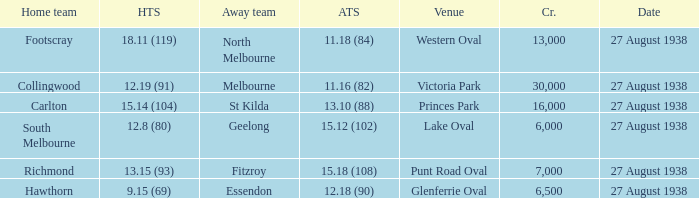How many people witnessed their home team score 13.15 (93)? 7000.0. 